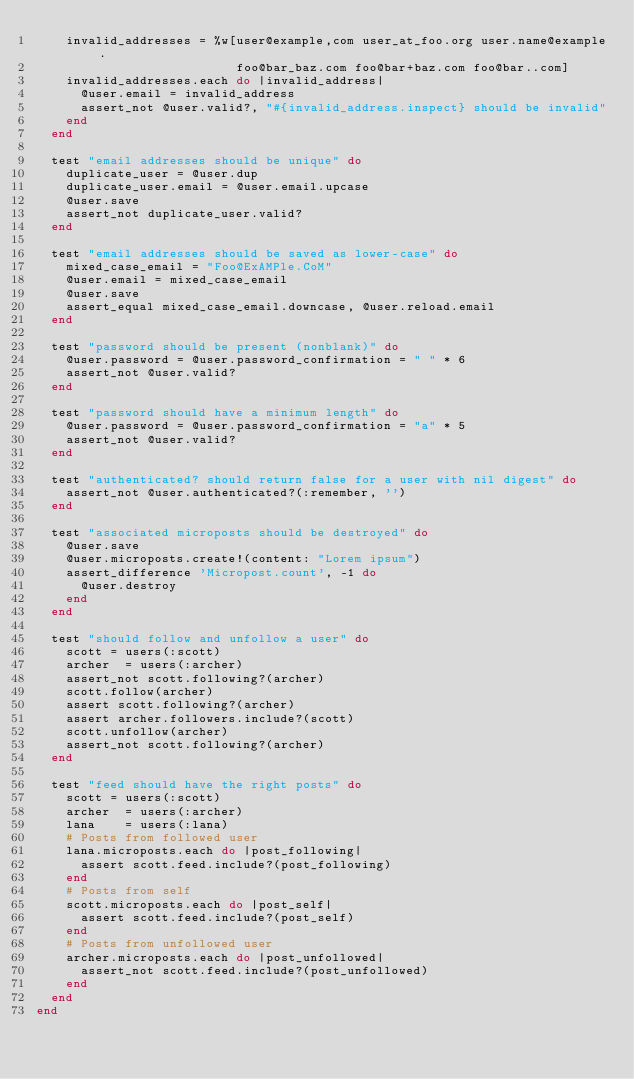Convert code to text. <code><loc_0><loc_0><loc_500><loc_500><_Ruby_>    invalid_addresses = %w[user@example,com user_at_foo.org user.name@example.
                           foo@bar_baz.com foo@bar+baz.com foo@bar..com]
    invalid_addresses.each do |invalid_address|
      @user.email = invalid_address
      assert_not @user.valid?, "#{invalid_address.inspect} should be invalid"
    end
  end
  
  test "email addresses should be unique" do
    duplicate_user = @user.dup
    duplicate_user.email = @user.email.upcase
    @user.save
    assert_not duplicate_user.valid?
  end
  
  test "email addresses should be saved as lower-case" do
    mixed_case_email = "Foo@ExAMPle.CoM"
    @user.email = mixed_case_email
    @user.save
    assert_equal mixed_case_email.downcase, @user.reload.email
  end
  
  test "password should be present (nonblank)" do
    @user.password = @user.password_confirmation = " " * 6
    assert_not @user.valid?
  end

  test "password should have a minimum length" do
    @user.password = @user.password_confirmation = "a" * 5
    assert_not @user.valid?
  end

  test "authenticated? should return false for a user with nil digest" do
    assert_not @user.authenticated?(:remember, '')
  end
  
  test "associated microposts should be destroyed" do
    @user.save
    @user.microposts.create!(content: "Lorem ipsum")
    assert_difference 'Micropost.count', -1 do
      @user.destroy
    end
  end
  
  test "should follow and unfollow a user" do
    scott = users(:scott)
    archer  = users(:archer)
    assert_not scott.following?(archer)
    scott.follow(archer)
    assert scott.following?(archer)
    assert archer.followers.include?(scott)
    scott.unfollow(archer)
    assert_not scott.following?(archer)
  end
  
  test "feed should have the right posts" do
    scott = users(:scott)
    archer  = users(:archer)
    lana    = users(:lana)
    # Posts from followed user
    lana.microposts.each do |post_following|
      assert scott.feed.include?(post_following)
    end
    # Posts from self
    scott.microposts.each do |post_self|
      assert scott.feed.include?(post_self)
    end
    # Posts from unfollowed user
    archer.microposts.each do |post_unfollowed|
      assert_not scott.feed.include?(post_unfollowed)
    end
  end
end
</code> 